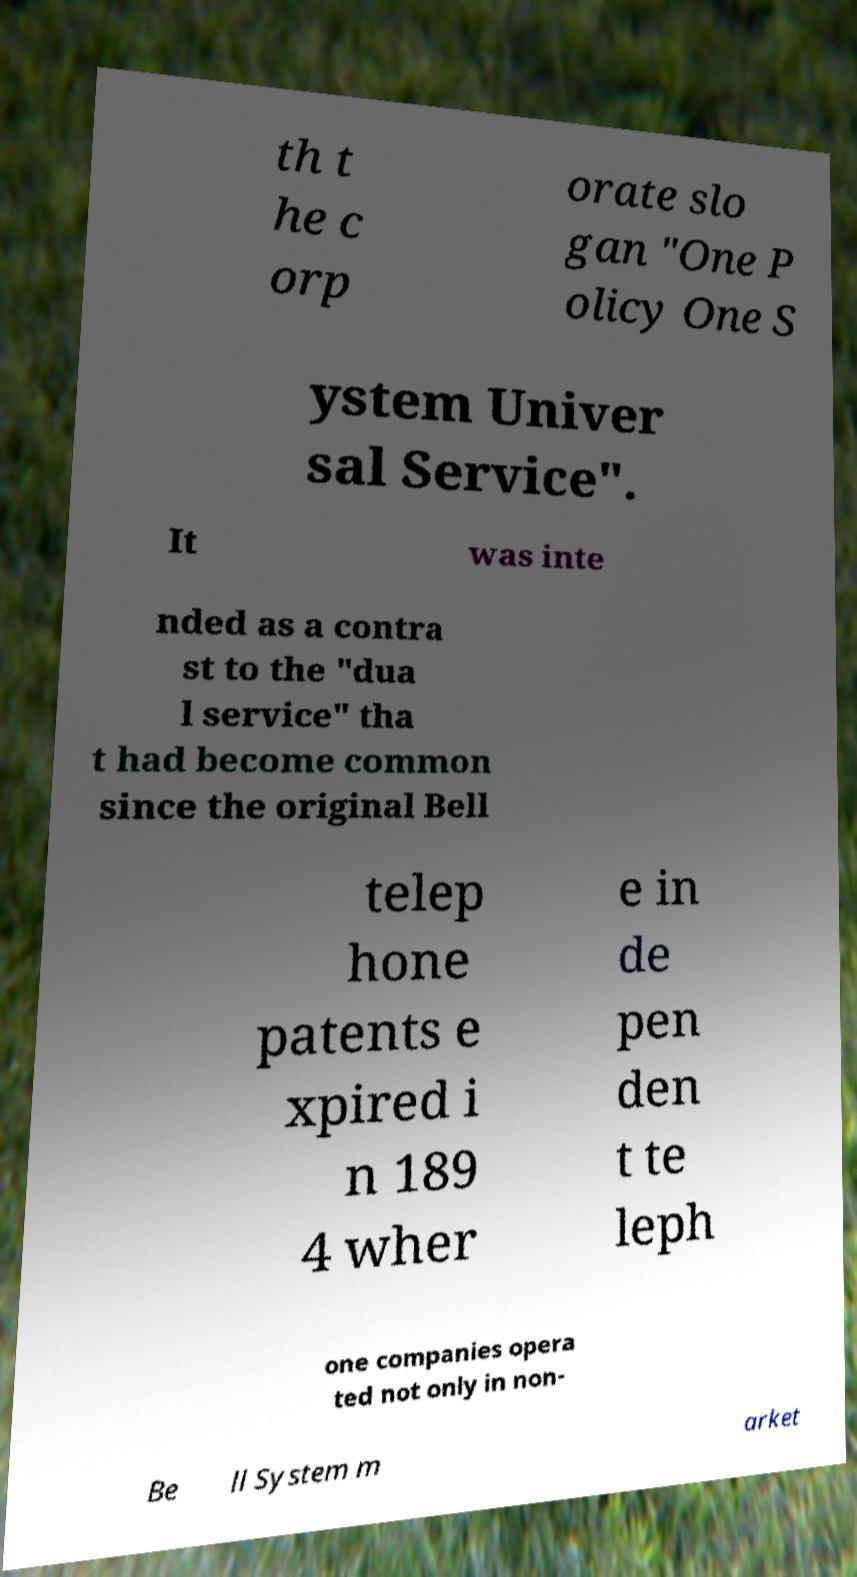Please identify and transcribe the text found in this image. th t he c orp orate slo gan "One P olicy One S ystem Univer sal Service". It was inte nded as a contra st to the "dua l service" tha t had become common since the original Bell telep hone patents e xpired i n 189 4 wher e in de pen den t te leph one companies opera ted not only in non- Be ll System m arket 